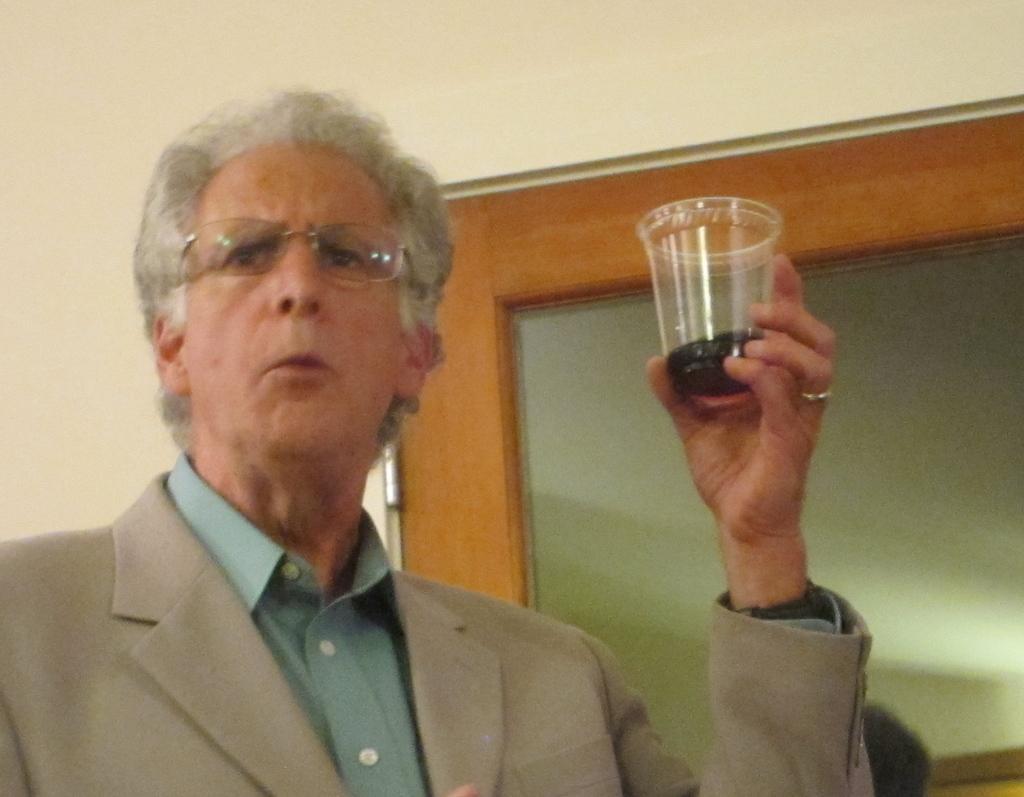Can you describe this image briefly? In this picture there is a person wearing suit is holding a glass of drink in his hand. 